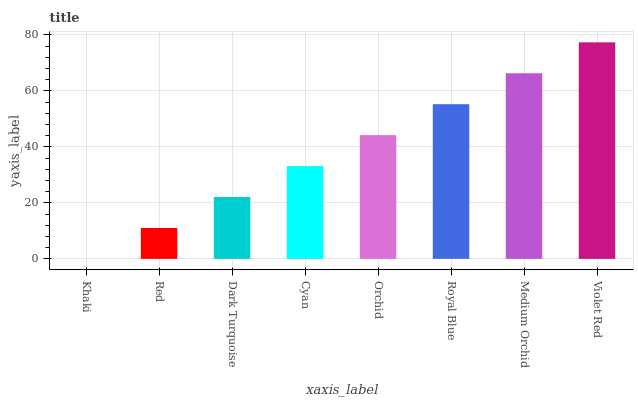Is Khaki the minimum?
Answer yes or no. Yes. Is Violet Red the maximum?
Answer yes or no. Yes. Is Red the minimum?
Answer yes or no. No. Is Red the maximum?
Answer yes or no. No. Is Red greater than Khaki?
Answer yes or no. Yes. Is Khaki less than Red?
Answer yes or no. Yes. Is Khaki greater than Red?
Answer yes or no. No. Is Red less than Khaki?
Answer yes or no. No. Is Orchid the high median?
Answer yes or no. Yes. Is Cyan the low median?
Answer yes or no. Yes. Is Cyan the high median?
Answer yes or no. No. Is Royal Blue the low median?
Answer yes or no. No. 